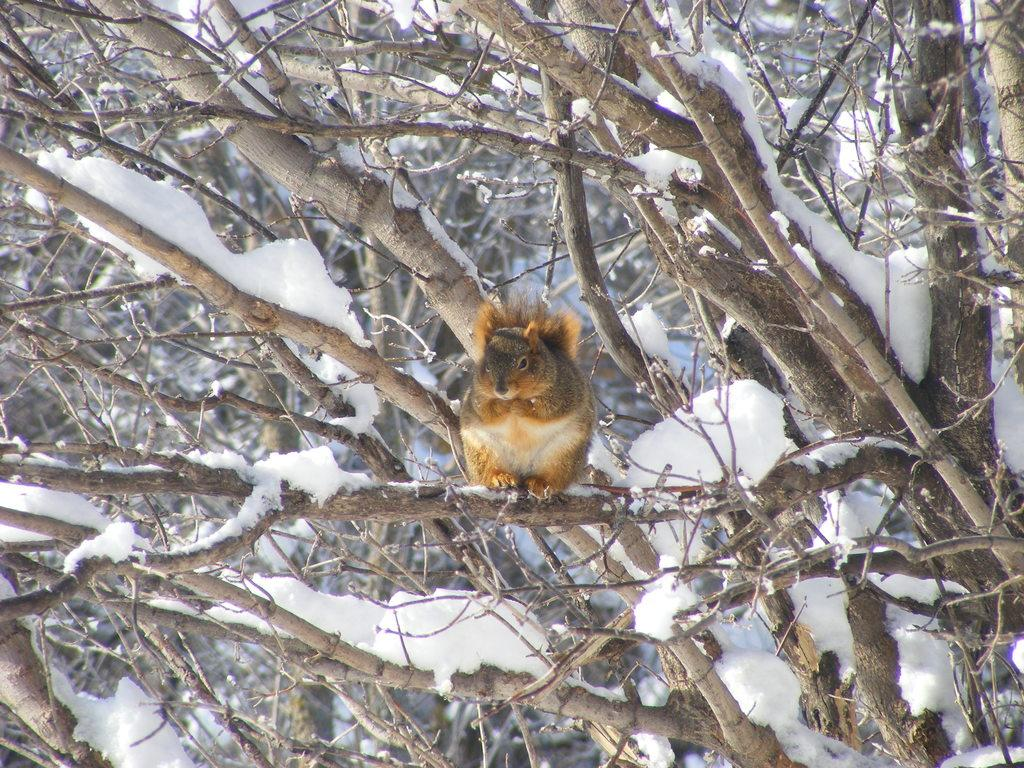What is the animal sitting on in the image? The animal is sitting on a branch of a tree in the image. How many trees can be seen in the image? There are multiple trees in the image. What is the weather like in the image? The presence of snow in the image suggests a cold or wintry environment. What type of linen is draped over the beds in the image? There are no beds present in the image; it features an animal sitting on a tree branch and multiple trees in a snowy environment. 